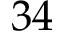Convert formula to latex. <formula><loc_0><loc_0><loc_500><loc_500>3 4</formula> 